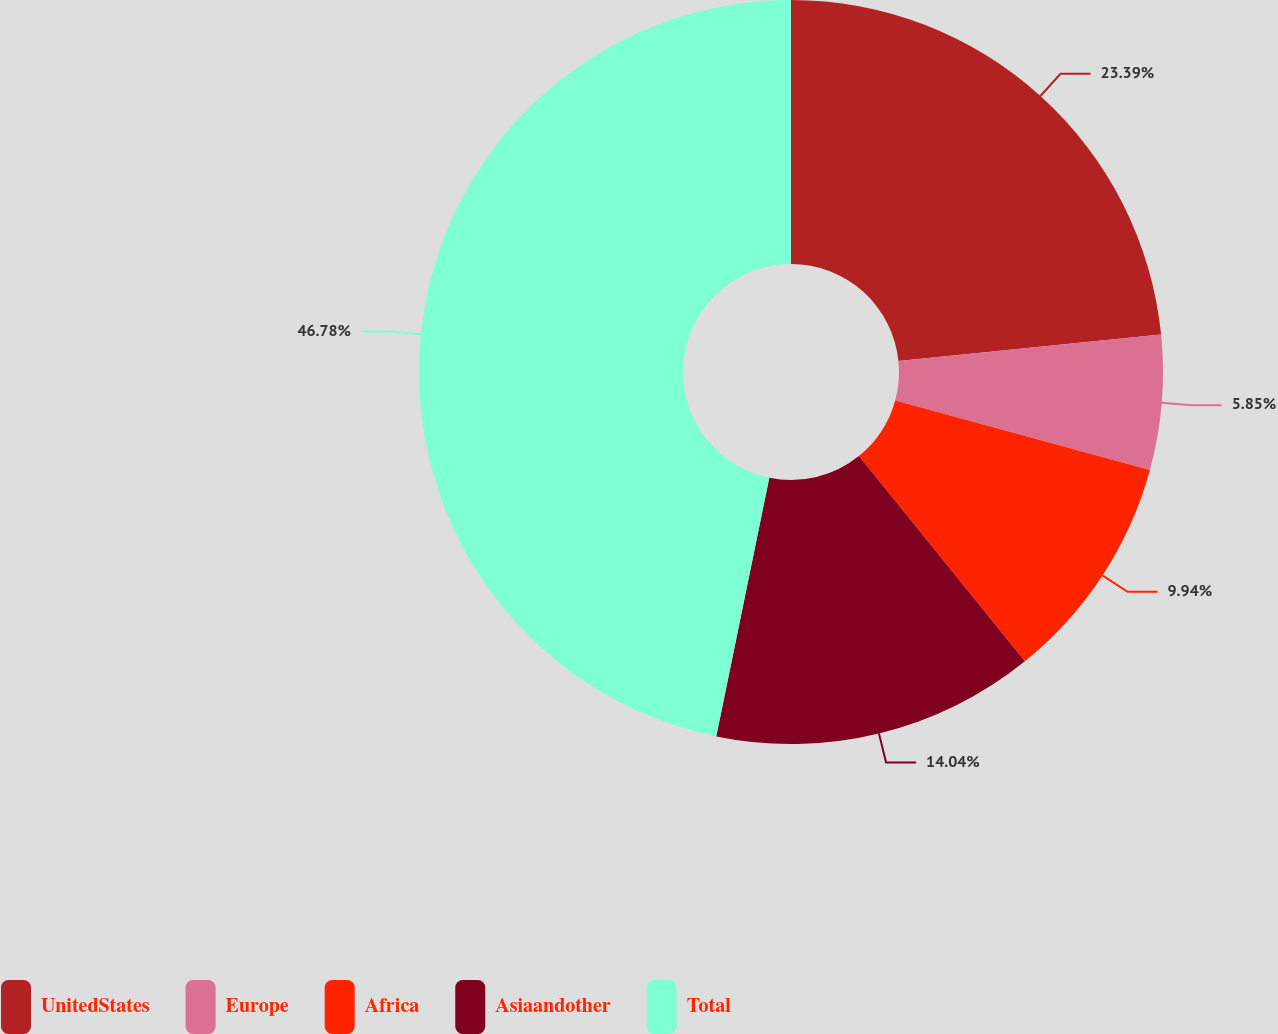Convert chart to OTSL. <chart><loc_0><loc_0><loc_500><loc_500><pie_chart><fcel>UnitedStates<fcel>Europe<fcel>Africa<fcel>Asiaandother<fcel>Total<nl><fcel>23.39%<fcel>5.85%<fcel>9.94%<fcel>14.04%<fcel>46.78%<nl></chart> 